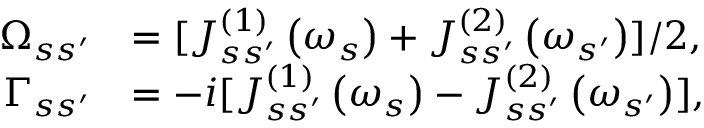Convert formula to latex. <formula><loc_0><loc_0><loc_500><loc_500>\begin{array} { r l } { \Omega _ { s s ^ { \prime } } } & { = [ J _ { s s ^ { \prime } } ^ { \left ( 1 \right ) } \left ( \omega _ { s } \right ) + J _ { s s ^ { \prime } } ^ { \left ( 2 \right ) } \left ( \omega _ { s ^ { \prime } } \right ) ] / 2 , } \\ { \Gamma _ { s s ^ { \prime } } } & { = - i [ J _ { s s ^ { \prime } } ^ { \left ( 1 \right ) } \left ( \omega _ { s } \right ) - J _ { s s ^ { \prime } } ^ { \left ( 2 \right ) } \left ( \omega _ { s ^ { \prime } } \right ) ] , } \end{array}</formula> 